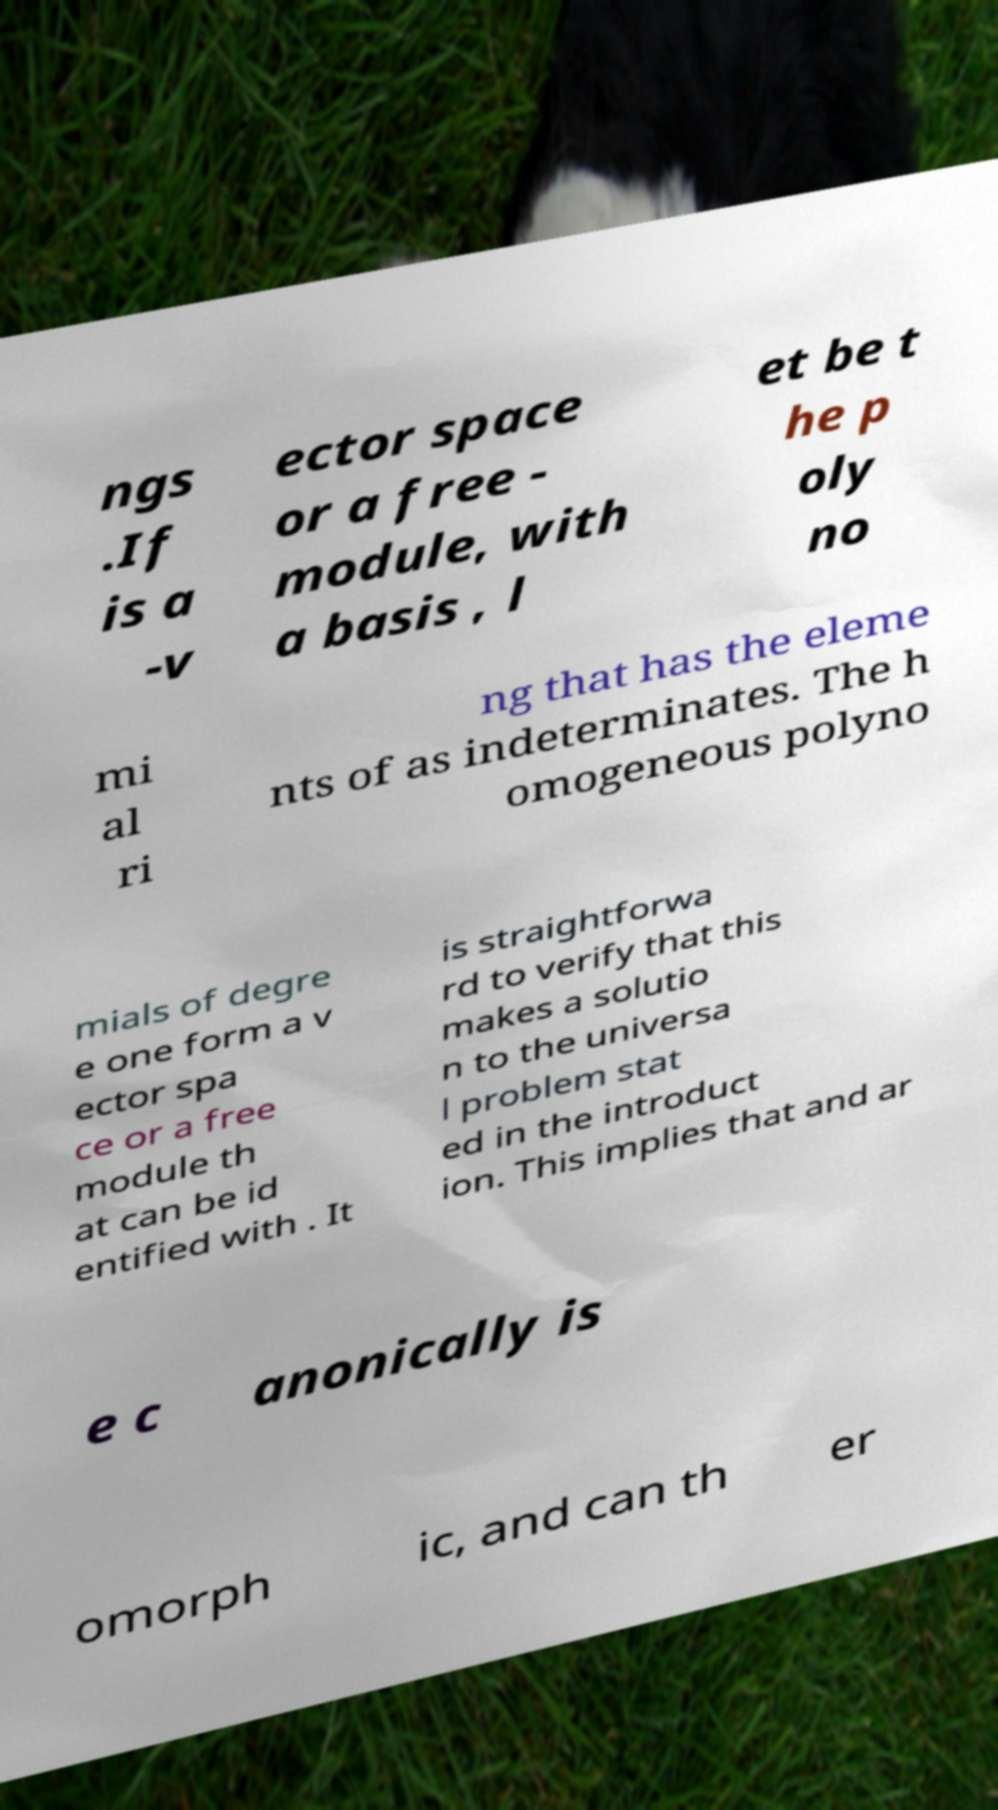What messages or text are displayed in this image? I need them in a readable, typed format. ngs .If is a -v ector space or a free - module, with a basis , l et be t he p oly no mi al ri ng that has the eleme nts of as indeterminates. The h omogeneous polyno mials of degre e one form a v ector spa ce or a free module th at can be id entified with . It is straightforwa rd to verify that this makes a solutio n to the universa l problem stat ed in the introduct ion. This implies that and ar e c anonically is omorph ic, and can th er 